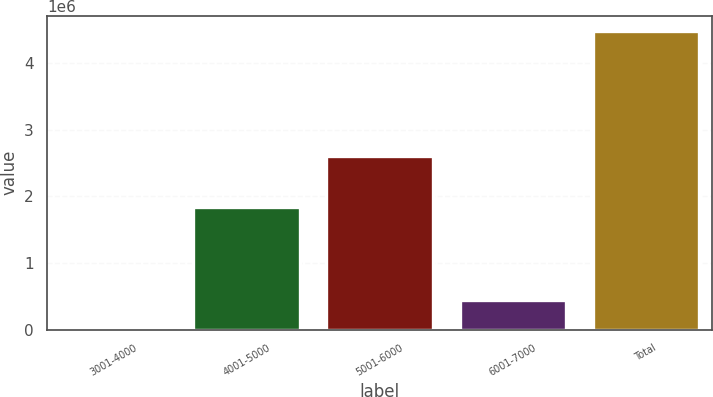Convert chart to OTSL. <chart><loc_0><loc_0><loc_500><loc_500><bar_chart><fcel>3001-4000<fcel>4001-5000<fcel>5001-6000<fcel>6001-7000<fcel>Total<nl><fcel>250<fcel>1.84456e+06<fcel>2.60309e+06<fcel>448458<fcel>4.48233e+06<nl></chart> 